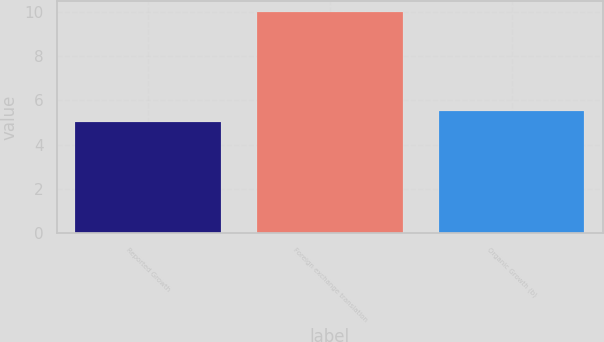<chart> <loc_0><loc_0><loc_500><loc_500><bar_chart><fcel>Reported Growth<fcel>Foreign exchange translation<fcel>Organic Growth (b)<nl><fcel>5<fcel>10<fcel>5.5<nl></chart> 